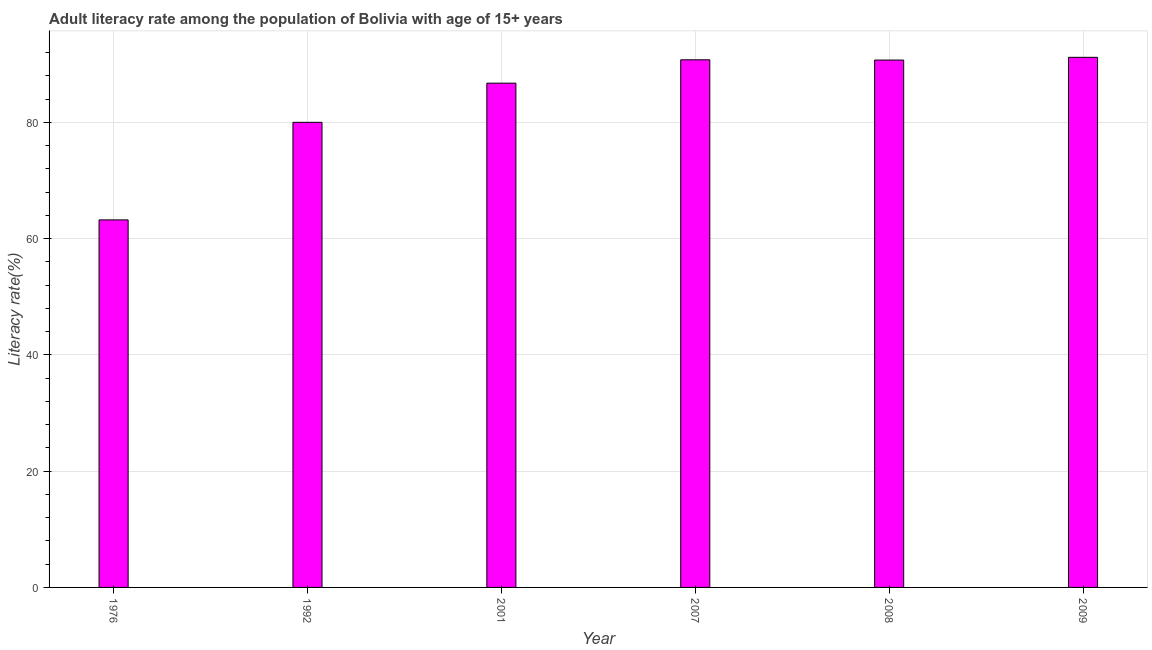What is the title of the graph?
Offer a terse response. Adult literacy rate among the population of Bolivia with age of 15+ years. What is the label or title of the Y-axis?
Provide a short and direct response. Literacy rate(%). What is the adult literacy rate in 1992?
Offer a terse response. 79.99. Across all years, what is the maximum adult literacy rate?
Your answer should be very brief. 91.17. Across all years, what is the minimum adult literacy rate?
Provide a succinct answer. 63.21. In which year was the adult literacy rate minimum?
Offer a terse response. 1976. What is the sum of the adult literacy rate?
Give a very brief answer. 502.53. What is the difference between the adult literacy rate in 2007 and 2009?
Provide a succinct answer. -0.42. What is the average adult literacy rate per year?
Your answer should be very brief. 83.75. What is the median adult literacy rate?
Provide a succinct answer. 88.71. In how many years, is the adult literacy rate greater than 44 %?
Provide a short and direct response. 6. Do a majority of the years between 2009 and 2007 (inclusive) have adult literacy rate greater than 4 %?
Keep it short and to the point. Yes. What is the ratio of the adult literacy rate in 2001 to that in 2008?
Offer a very short reply. 0.96. Is the adult literacy rate in 1976 less than that in 2009?
Make the answer very short. Yes. What is the difference between the highest and the second highest adult literacy rate?
Make the answer very short. 0.42. Is the sum of the adult literacy rate in 1976 and 2009 greater than the maximum adult literacy rate across all years?
Provide a short and direct response. Yes. What is the difference between the highest and the lowest adult literacy rate?
Provide a short and direct response. 27.96. How many bars are there?
Your answer should be compact. 6. Are all the bars in the graph horizontal?
Keep it short and to the point. No. How many years are there in the graph?
Your answer should be compact. 6. Are the values on the major ticks of Y-axis written in scientific E-notation?
Your answer should be compact. No. What is the Literacy rate(%) in 1976?
Give a very brief answer. 63.21. What is the Literacy rate(%) in 1992?
Make the answer very short. 79.99. What is the Literacy rate(%) in 2001?
Your response must be concise. 86.72. What is the Literacy rate(%) in 2007?
Keep it short and to the point. 90.74. What is the Literacy rate(%) of 2008?
Provide a succinct answer. 90.7. What is the Literacy rate(%) in 2009?
Provide a short and direct response. 91.17. What is the difference between the Literacy rate(%) in 1976 and 1992?
Your response must be concise. -16.78. What is the difference between the Literacy rate(%) in 1976 and 2001?
Give a very brief answer. -23.52. What is the difference between the Literacy rate(%) in 1976 and 2007?
Provide a short and direct response. -27.54. What is the difference between the Literacy rate(%) in 1976 and 2008?
Offer a terse response. -27.49. What is the difference between the Literacy rate(%) in 1976 and 2009?
Your response must be concise. -27.96. What is the difference between the Literacy rate(%) in 1992 and 2001?
Your answer should be compact. -6.73. What is the difference between the Literacy rate(%) in 1992 and 2007?
Offer a terse response. -10.75. What is the difference between the Literacy rate(%) in 1992 and 2008?
Keep it short and to the point. -10.71. What is the difference between the Literacy rate(%) in 1992 and 2009?
Ensure brevity in your answer.  -11.18. What is the difference between the Literacy rate(%) in 2001 and 2007?
Your answer should be very brief. -4.02. What is the difference between the Literacy rate(%) in 2001 and 2008?
Provide a short and direct response. -3.97. What is the difference between the Literacy rate(%) in 2001 and 2009?
Offer a terse response. -4.44. What is the difference between the Literacy rate(%) in 2007 and 2008?
Provide a short and direct response. 0.05. What is the difference between the Literacy rate(%) in 2007 and 2009?
Provide a short and direct response. -0.42. What is the difference between the Literacy rate(%) in 2008 and 2009?
Ensure brevity in your answer.  -0.47. What is the ratio of the Literacy rate(%) in 1976 to that in 1992?
Keep it short and to the point. 0.79. What is the ratio of the Literacy rate(%) in 1976 to that in 2001?
Keep it short and to the point. 0.73. What is the ratio of the Literacy rate(%) in 1976 to that in 2007?
Provide a succinct answer. 0.7. What is the ratio of the Literacy rate(%) in 1976 to that in 2008?
Offer a terse response. 0.7. What is the ratio of the Literacy rate(%) in 1976 to that in 2009?
Provide a short and direct response. 0.69. What is the ratio of the Literacy rate(%) in 1992 to that in 2001?
Offer a terse response. 0.92. What is the ratio of the Literacy rate(%) in 1992 to that in 2007?
Your answer should be compact. 0.88. What is the ratio of the Literacy rate(%) in 1992 to that in 2008?
Keep it short and to the point. 0.88. What is the ratio of the Literacy rate(%) in 1992 to that in 2009?
Provide a succinct answer. 0.88. What is the ratio of the Literacy rate(%) in 2001 to that in 2007?
Ensure brevity in your answer.  0.96. What is the ratio of the Literacy rate(%) in 2001 to that in 2008?
Your answer should be very brief. 0.96. What is the ratio of the Literacy rate(%) in 2001 to that in 2009?
Keep it short and to the point. 0.95. What is the ratio of the Literacy rate(%) in 2007 to that in 2008?
Your answer should be compact. 1. 